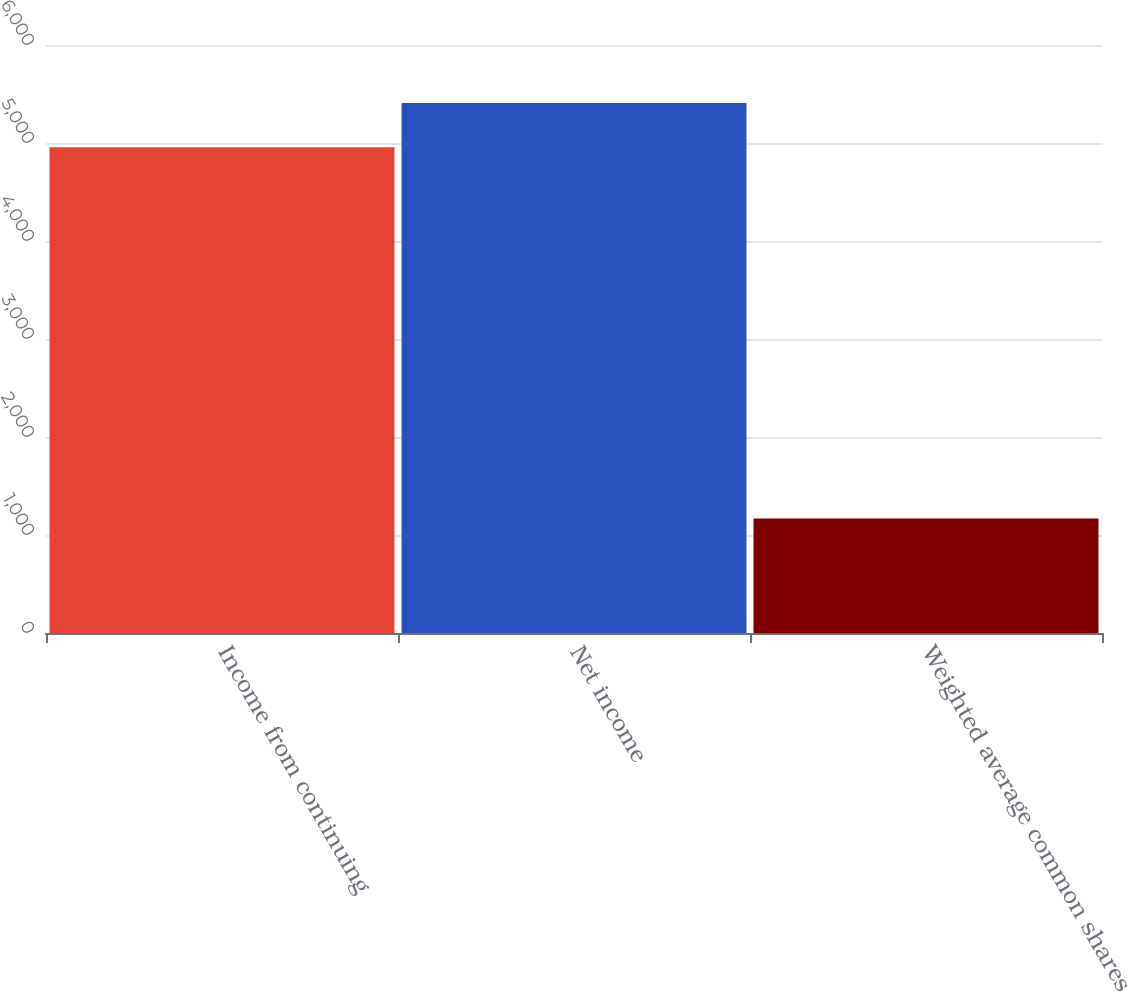Convert chart to OTSL. <chart><loc_0><loc_0><loc_500><loc_500><bar_chart><fcel>Income from continuing<fcel>Net income<fcel>Weighted average common shares<nl><fcel>4957<fcel>5408.8<fcel>1167.8<nl></chart> 